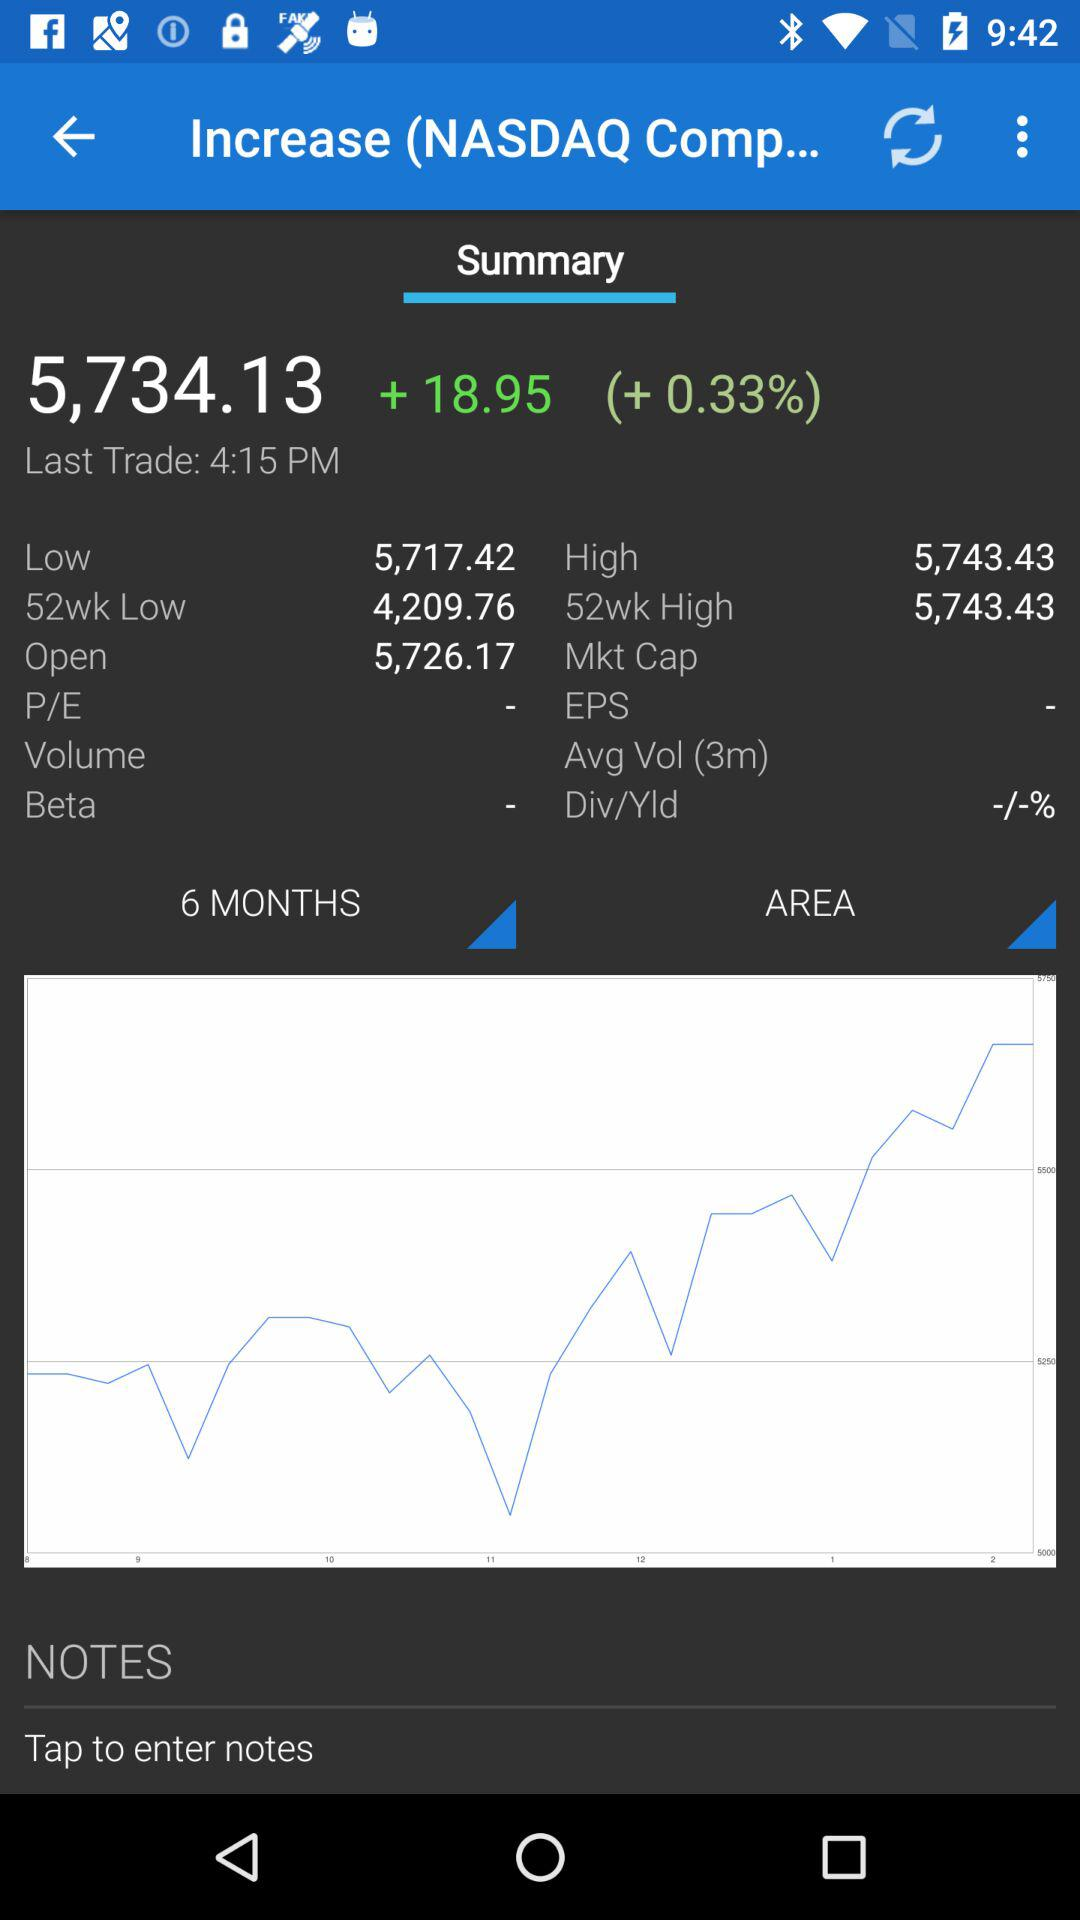By what percentage is the NASDAQ up? It is up by 0.33%. 